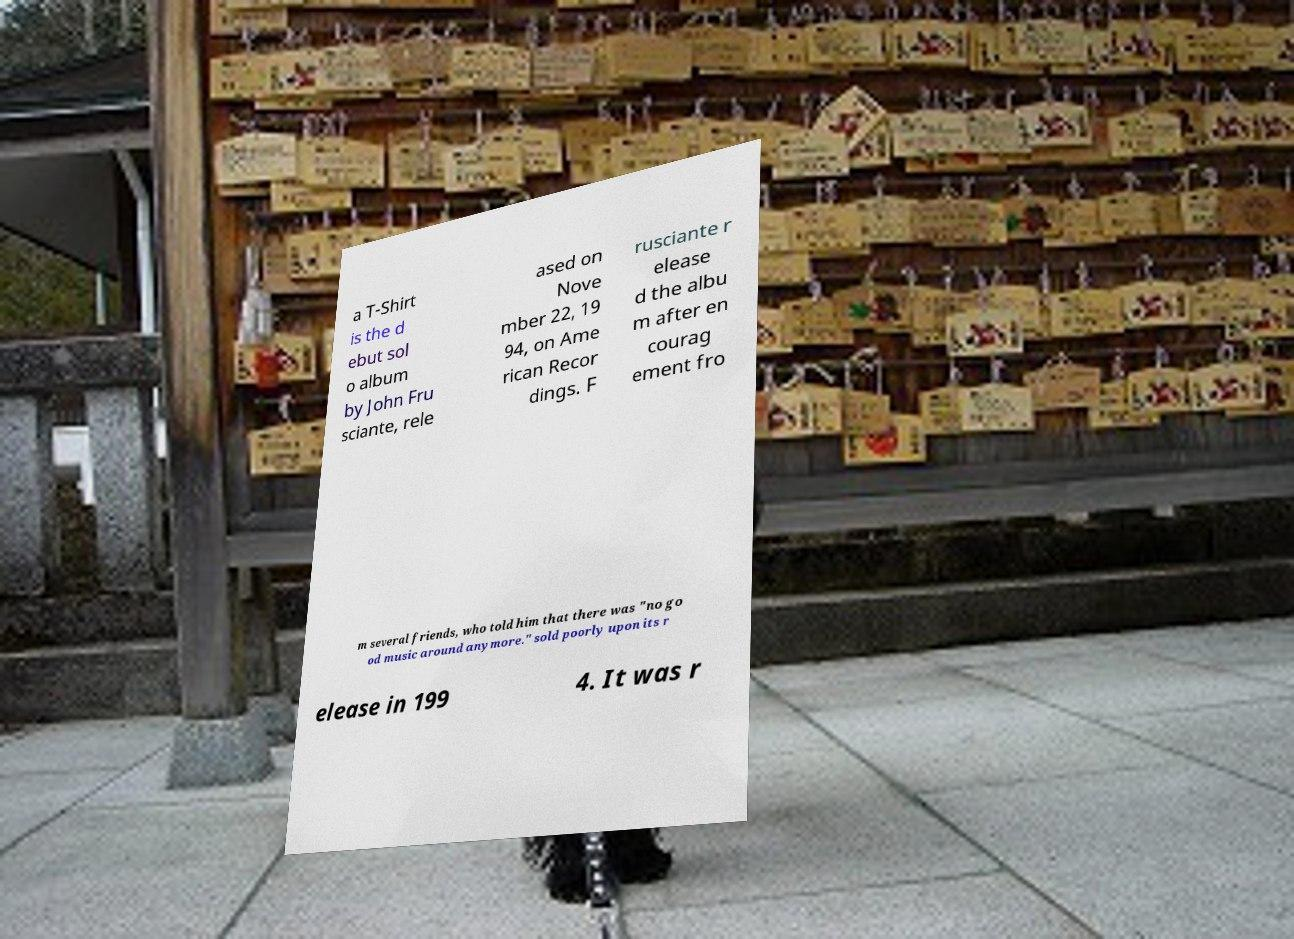Please identify and transcribe the text found in this image. a T-Shirt is the d ebut sol o album by John Fru sciante, rele ased on Nove mber 22, 19 94, on Ame rican Recor dings. F rusciante r elease d the albu m after en courag ement fro m several friends, who told him that there was "no go od music around anymore." sold poorly upon its r elease in 199 4. It was r 